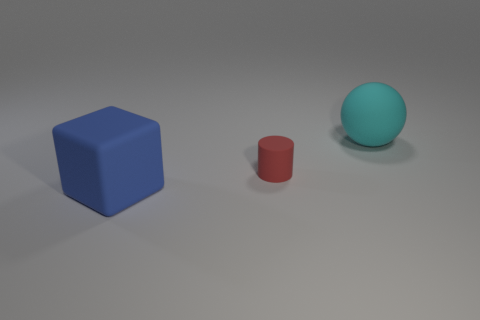Is the material of the thing that is behind the small red rubber cylinder the same as the large blue thing?
Your answer should be compact. Yes. Are there fewer green shiny objects than cyan spheres?
Provide a short and direct response. Yes. There is a big thing that is right of the rubber thing that is in front of the red rubber thing; is there a big blue object on the right side of it?
Your answer should be very brief. No. There is a large object that is right of the big blue block; is its shape the same as the small matte object?
Offer a very short reply. No. Are there more small red objects right of the cylinder than blue matte blocks?
Keep it short and to the point. No. Do the big thing that is in front of the cyan sphere and the big rubber ball have the same color?
Provide a short and direct response. No. Are there any other things that have the same color as the cylinder?
Offer a very short reply. No. The large rubber thing that is to the left of the big matte thing behind the large rubber object that is to the left of the red rubber cylinder is what color?
Provide a succinct answer. Blue. Is the size of the cylinder the same as the rubber cube?
Your response must be concise. No. What number of cyan metal balls are the same size as the cube?
Offer a terse response. 0. 